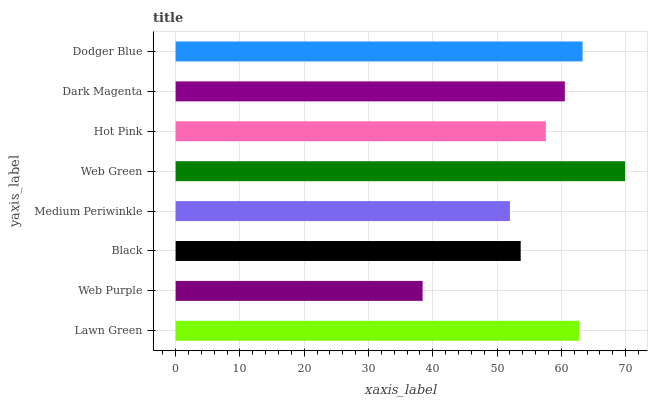Is Web Purple the minimum?
Answer yes or no. Yes. Is Web Green the maximum?
Answer yes or no. Yes. Is Black the minimum?
Answer yes or no. No. Is Black the maximum?
Answer yes or no. No. Is Black greater than Web Purple?
Answer yes or no. Yes. Is Web Purple less than Black?
Answer yes or no. Yes. Is Web Purple greater than Black?
Answer yes or no. No. Is Black less than Web Purple?
Answer yes or no. No. Is Dark Magenta the high median?
Answer yes or no. Yes. Is Hot Pink the low median?
Answer yes or no. Yes. Is Medium Periwinkle the high median?
Answer yes or no. No. Is Black the low median?
Answer yes or no. No. 